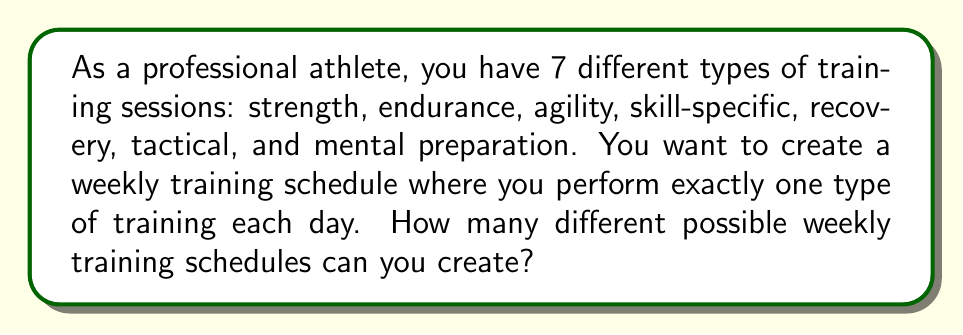Solve this math problem. Let's approach this step-by-step:

1) We have 7 days in a week, and for each day, we need to choose one of the 7 types of training sessions.

2) This is a perfect scenario for using the multiplication principle of counting.

3) For each day:
   - We have 7 choices of training sessions
   - Our choice for one day does not affect our choices for other days (we can repeat training types on different days)

4) According to the multiplication principle, if we have a series of independent choices, we multiply the number of options for each choice.

5) In this case, we have 7 independent choices (one for each day of the week), and each choice has 7 options.

6) Therefore, the total number of possible schedules is:

   $$ 7 \times 7 \times 7 \times 7 \times 7 \times 7 \times 7 = 7^7 $$

7) Calculating this:
   $$ 7^7 = 823,543 $$

Thus, there are 823,543 different possible weekly training schedules.
Answer: $7^7 = 823,543$ 